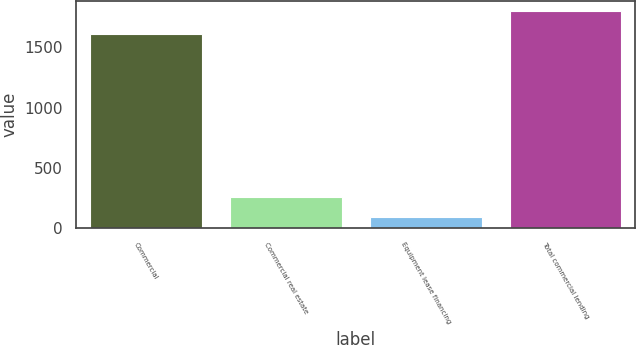<chart> <loc_0><loc_0><loc_500><loc_500><bar_chart><fcel>Commercial<fcel>Commercial real estate<fcel>Equipment lease financing<fcel>Total commercial lending<nl><fcel>1612<fcel>260<fcel>89<fcel>1799<nl></chart> 